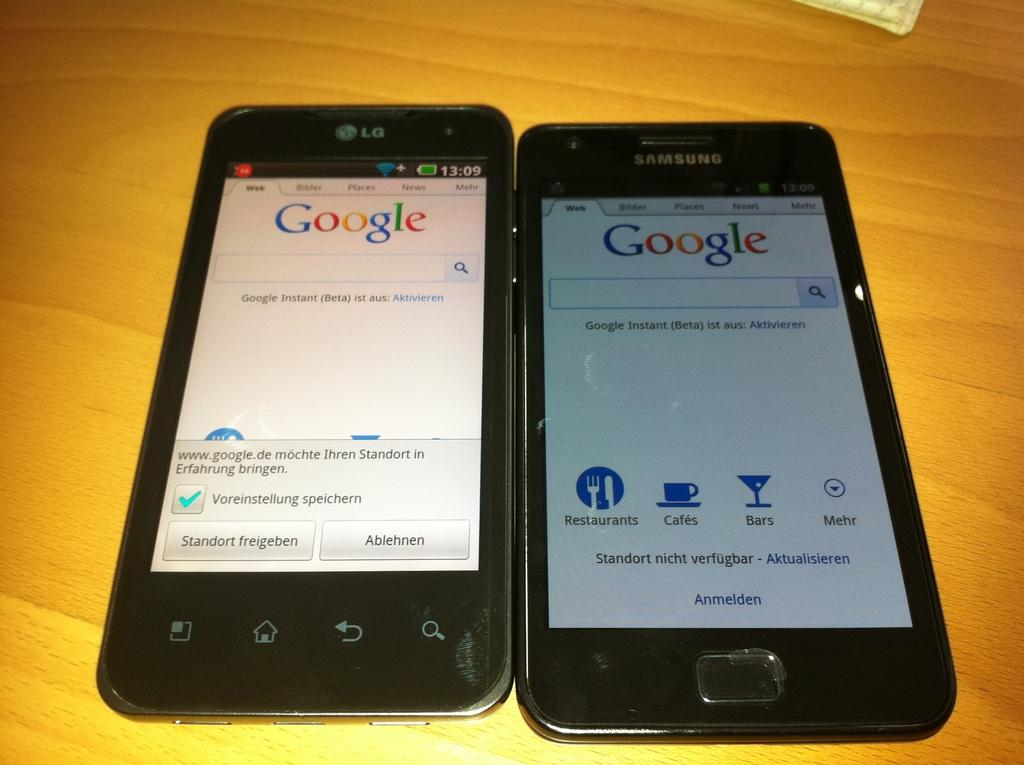<image>
Render a clear and concise summary of the photo. Two phones are side by side with the Google search page open. 